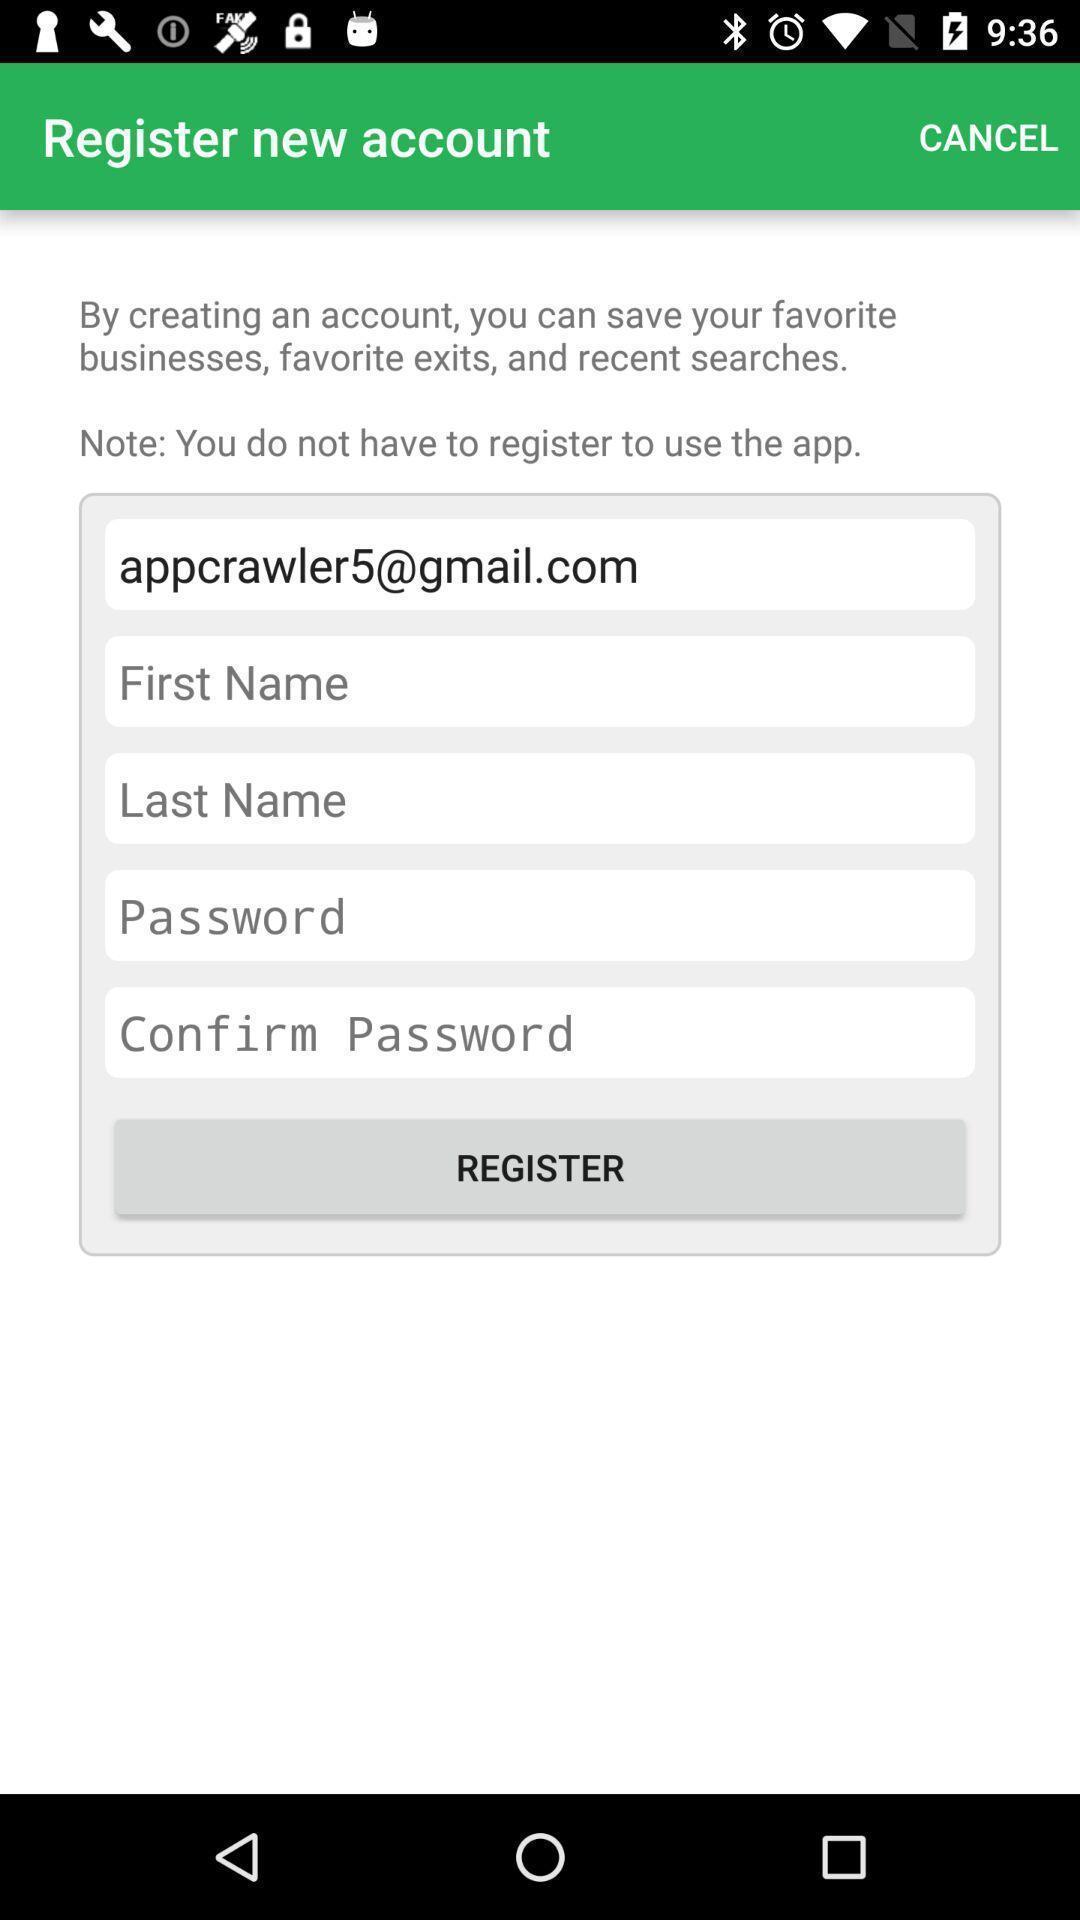Provide a description of this screenshot. Screen displaying multiple options in registration page. 